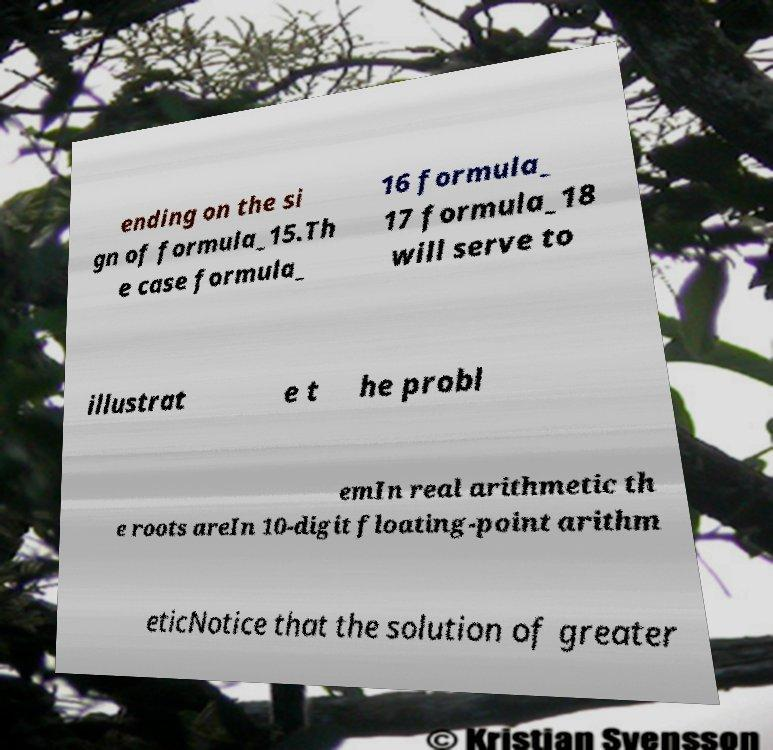For documentation purposes, I need the text within this image transcribed. Could you provide that? ending on the si gn of formula_15.Th e case formula_ 16 formula_ 17 formula_18 will serve to illustrat e t he probl emIn real arithmetic th e roots areIn 10-digit floating-point arithm eticNotice that the solution of greater 